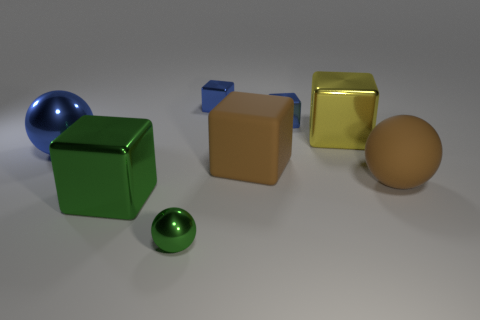There is a small block that is on the left side of the matte block; is its color the same as the large shiny sphere?
Keep it short and to the point. Yes. Is the number of large metal blocks that are behind the green ball less than the number of big objects?
Your response must be concise. Yes. The big sphere that is made of the same material as the yellow thing is what color?
Offer a very short reply. Blue. How big is the green metallic thing that is in front of the large green metal cube?
Offer a terse response. Small. Is the material of the small green ball the same as the yellow object?
Make the answer very short. Yes. There is a matte cube behind the large ball that is in front of the large blue thing; is there a large metal object that is behind it?
Keep it short and to the point. Yes. What color is the matte ball?
Your answer should be compact. Brown. What color is the metallic sphere that is the same size as the green block?
Your answer should be very brief. Blue. There is a green object that is behind the green metallic ball; is it the same shape as the large blue metal object?
Offer a very short reply. No. The big shiny block to the left of the green thing on the right side of the big metallic cube in front of the large blue sphere is what color?
Ensure brevity in your answer.  Green. 